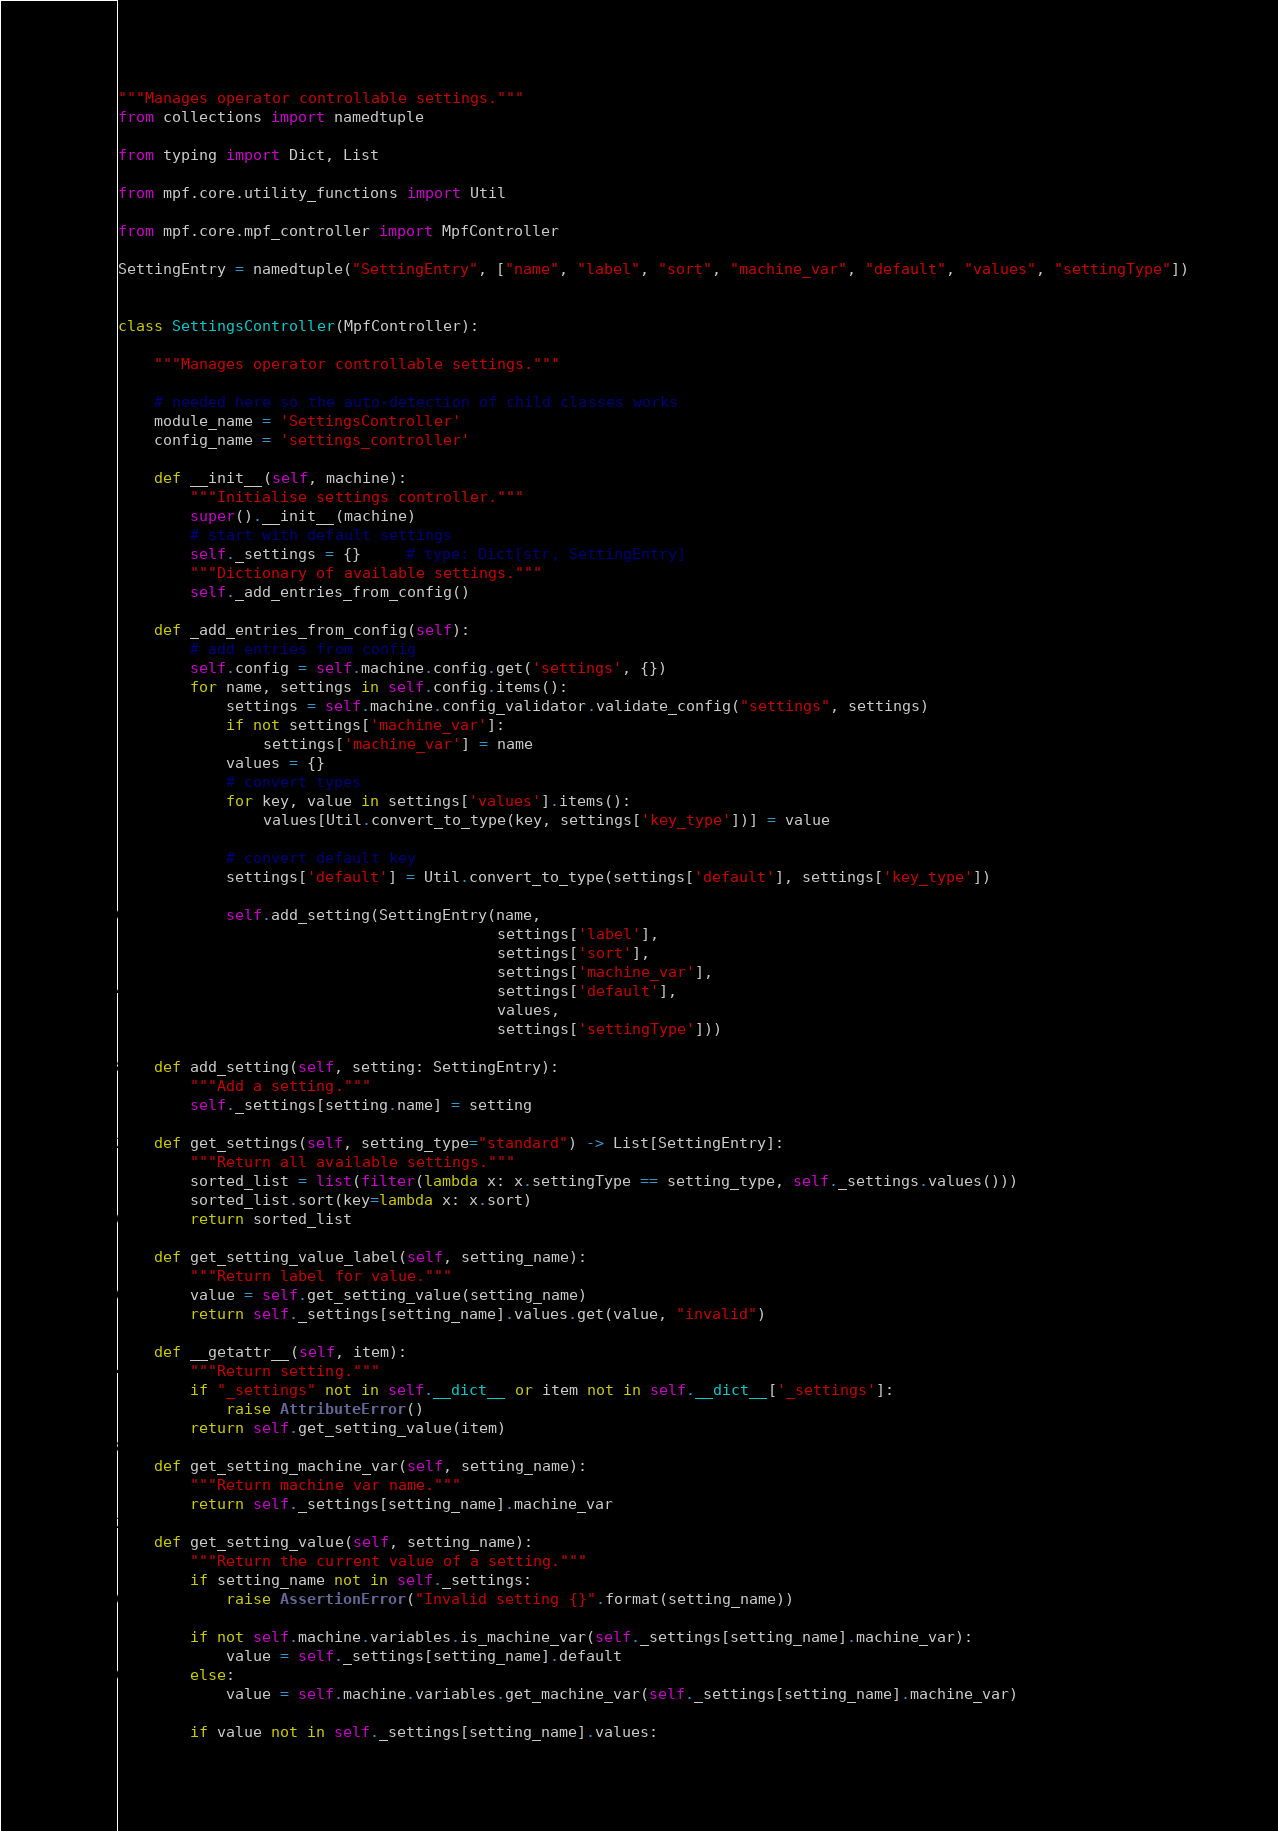Convert code to text. <code><loc_0><loc_0><loc_500><loc_500><_Python_>"""Manages operator controllable settings."""
from collections import namedtuple

from typing import Dict, List

from mpf.core.utility_functions import Util

from mpf.core.mpf_controller import MpfController

SettingEntry = namedtuple("SettingEntry", ["name", "label", "sort", "machine_var", "default", "values", "settingType"])


class SettingsController(MpfController):

    """Manages operator controllable settings."""

    # needed here so the auto-detection of child classes works
    module_name = 'SettingsController'
    config_name = 'settings_controller'

    def __init__(self, machine):
        """Initialise settings controller."""
        super().__init__(machine)
        # start with default settings
        self._settings = {}     # type: Dict[str, SettingEntry]
        """Dictionary of available settings."""
        self._add_entries_from_config()

    def _add_entries_from_config(self):
        # add entries from config
        self.config = self.machine.config.get('settings', {})
        for name, settings in self.config.items():
            settings = self.machine.config_validator.validate_config("settings", settings)
            if not settings['machine_var']:
                settings['machine_var'] = name
            values = {}
            # convert types
            for key, value in settings['values'].items():
                values[Util.convert_to_type(key, settings['key_type'])] = value

            # convert default key
            settings['default'] = Util.convert_to_type(settings['default'], settings['key_type'])

            self.add_setting(SettingEntry(name,
                                          settings['label'],
                                          settings['sort'],
                                          settings['machine_var'],
                                          settings['default'],
                                          values,
                                          settings['settingType']))

    def add_setting(self, setting: SettingEntry):
        """Add a setting."""
        self._settings[setting.name] = setting

    def get_settings(self, setting_type="standard") -> List[SettingEntry]:
        """Return all available settings."""
        sorted_list = list(filter(lambda x: x.settingType == setting_type, self._settings.values()))
        sorted_list.sort(key=lambda x: x.sort)
        return sorted_list

    def get_setting_value_label(self, setting_name):
        """Return label for value."""
        value = self.get_setting_value(setting_name)
        return self._settings[setting_name].values.get(value, "invalid")

    def __getattr__(self, item):
        """Return setting."""
        if "_settings" not in self.__dict__ or item not in self.__dict__['_settings']:
            raise AttributeError()
        return self.get_setting_value(item)

    def get_setting_machine_var(self, setting_name):
        """Return machine var name."""
        return self._settings[setting_name].machine_var

    def get_setting_value(self, setting_name):
        """Return the current value of a setting."""
        if setting_name not in self._settings:
            raise AssertionError("Invalid setting {}".format(setting_name))

        if not self.machine.variables.is_machine_var(self._settings[setting_name].machine_var):
            value = self._settings[setting_name].default
        else:
            value = self.machine.variables.get_machine_var(self._settings[setting_name].machine_var)

        if value not in self._settings[setting_name].values:</code> 